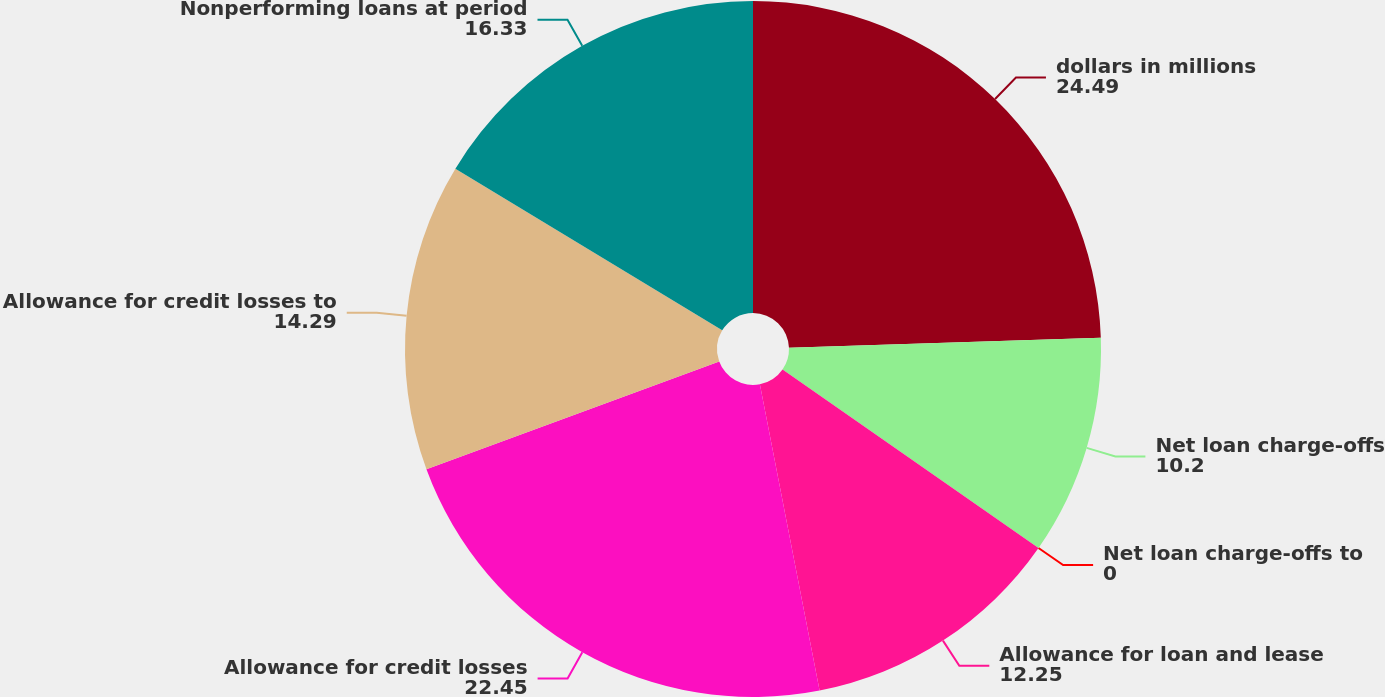Convert chart to OTSL. <chart><loc_0><loc_0><loc_500><loc_500><pie_chart><fcel>dollars in millions<fcel>Net loan charge-offs<fcel>Net loan charge-offs to<fcel>Allowance for loan and lease<fcel>Allowance for credit losses<fcel>Allowance for credit losses to<fcel>Nonperforming loans at period<nl><fcel>24.49%<fcel>10.2%<fcel>0.0%<fcel>12.25%<fcel>22.45%<fcel>14.29%<fcel>16.33%<nl></chart> 